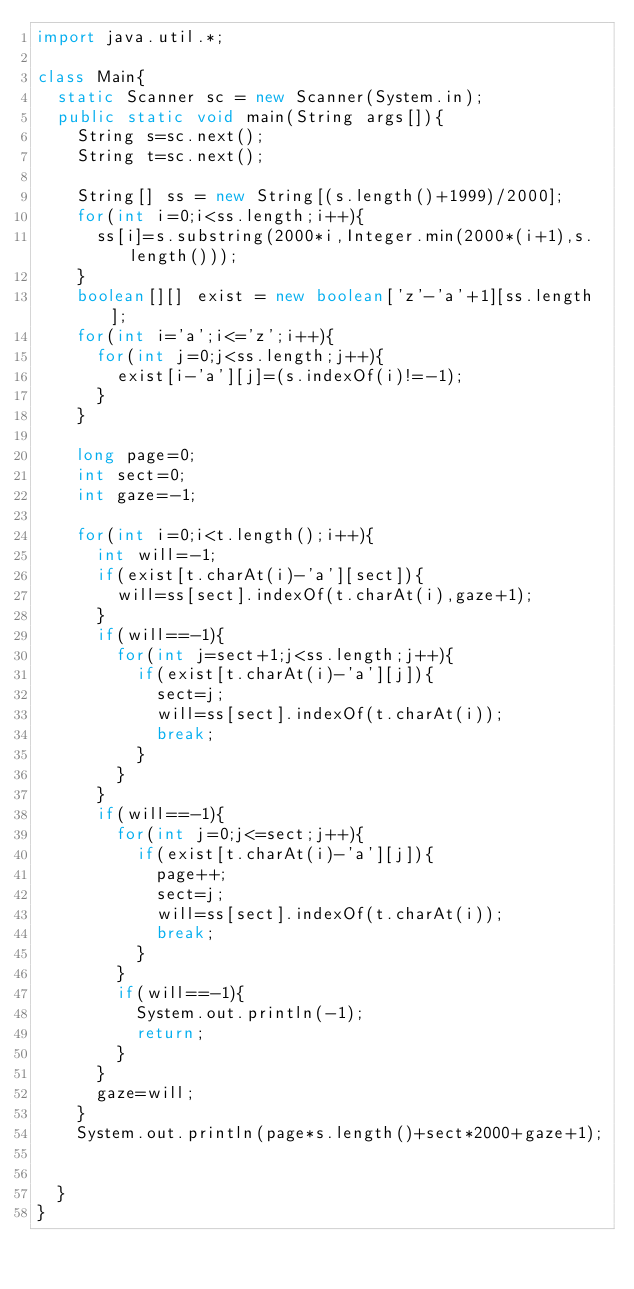Convert code to text. <code><loc_0><loc_0><loc_500><loc_500><_Java_>import java.util.*;

class Main{
  static Scanner sc = new Scanner(System.in);
  public static void main(String args[]){
    String s=sc.next();
    String t=sc.next();
    
    String[] ss = new String[(s.length()+1999)/2000];
    for(int i=0;i<ss.length;i++){
      ss[i]=s.substring(2000*i,Integer.min(2000*(i+1),s.length()));
    }
    boolean[][] exist = new boolean['z'-'a'+1][ss.length];
    for(int i='a';i<='z';i++){
      for(int j=0;j<ss.length;j++){
        exist[i-'a'][j]=(s.indexOf(i)!=-1);
      }
    }
    
    long page=0;
    int sect=0;
    int gaze=-1;
    
    for(int i=0;i<t.length();i++){
      int will=-1;
      if(exist[t.charAt(i)-'a'][sect]){
        will=ss[sect].indexOf(t.charAt(i),gaze+1);
      }
      if(will==-1){
        for(int j=sect+1;j<ss.length;j++){
          if(exist[t.charAt(i)-'a'][j]){
            sect=j;
            will=ss[sect].indexOf(t.charAt(i));
            break;
          }
        }
      }
      if(will==-1){
        for(int j=0;j<=sect;j++){
          if(exist[t.charAt(i)-'a'][j]){
            page++;
            sect=j;
            will=ss[sect].indexOf(t.charAt(i));
            break;
          }
        }
        if(will==-1){
          System.out.println(-1);
          return;
        }
      }
      gaze=will;
    }
    System.out.println(page*s.length()+sect*2000+gaze+1);
    
    
  }
}</code> 